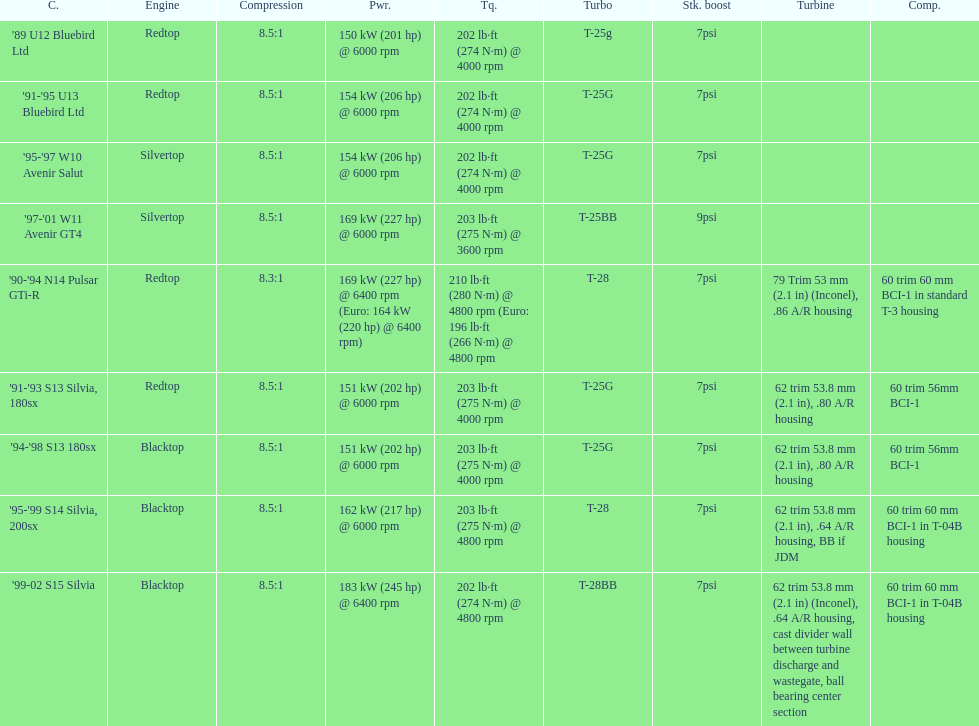Which automobile comes with a standard boost exceeding 7psi? '97-'01 W11 Avenir GT4. 